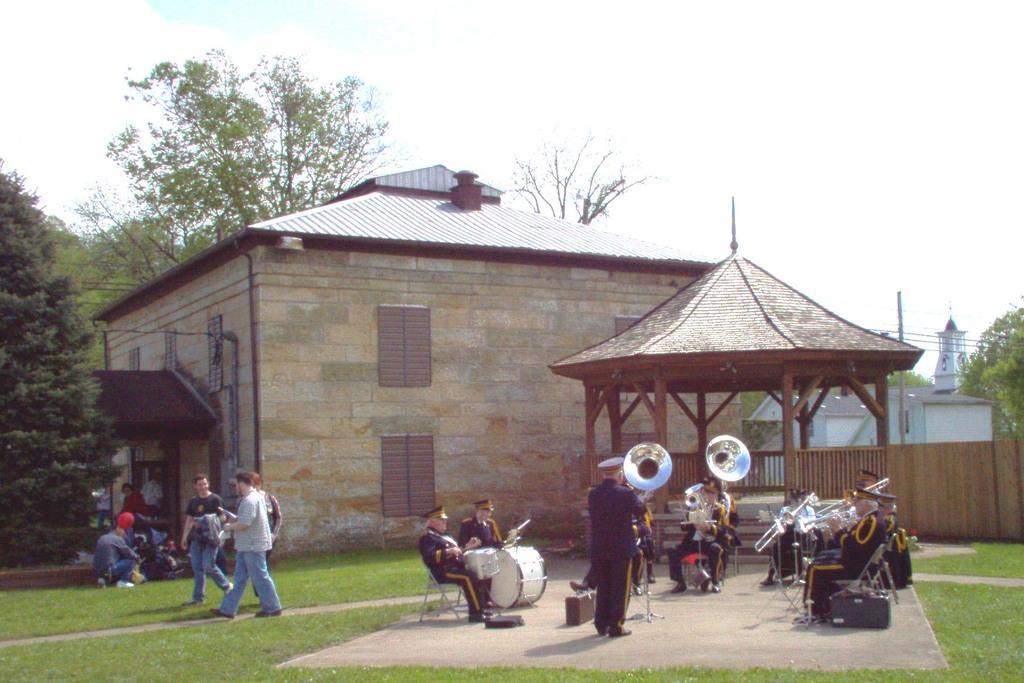Please provide a concise description of this image. In this image in the front there's grass on the ground. In the center there are persons playing musical instruments. On the left side there are persons walking and sitting. In the background there are houses, trees, there is a shelter and there is a wooden fence at the top there is sky. 